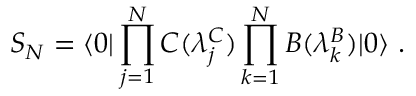Convert formula to latex. <formula><loc_0><loc_0><loc_500><loc_500>{ S } _ { N } = { \langle 0 | \prod _ { j = 1 } ^ { N } C ( \lambda _ { j } ^ { C } ) \prod _ { k = 1 } ^ { N } B ( \lambda _ { k } ^ { B } ) | 0 \rangle } \ .</formula> 